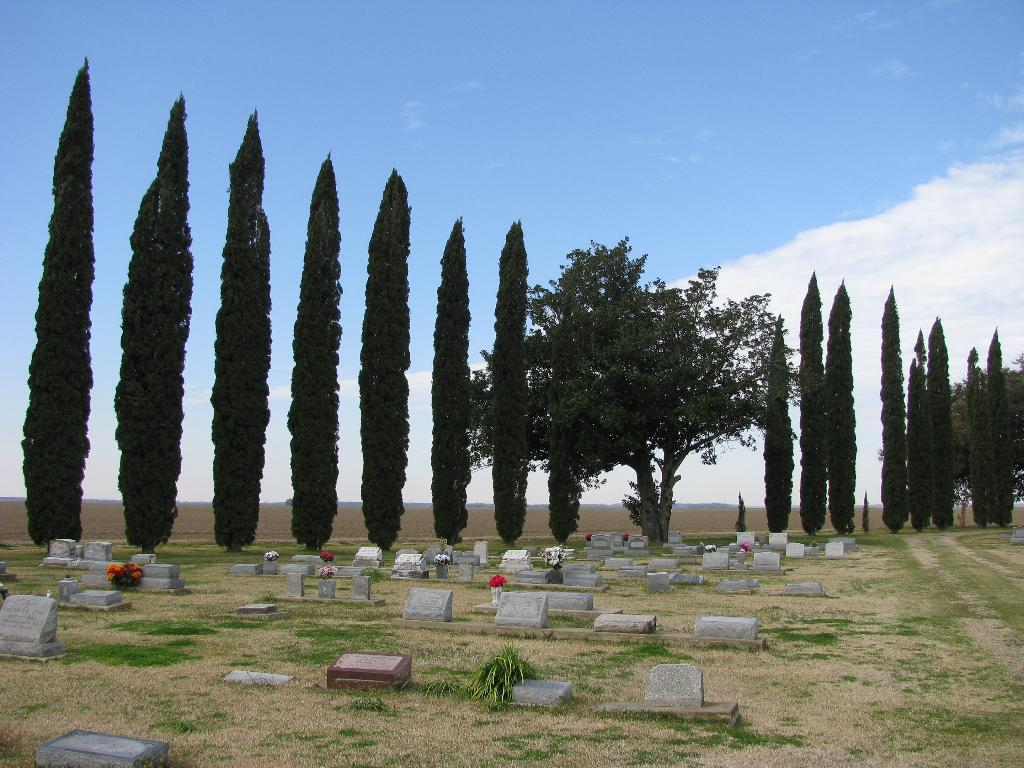What type of vegetation is present in the image? There are tall trees in the image. What can be seen in front of the trees? There are many stones in front of the trees. What might the stones resemble? The stones resemble grave stones. What memory does the son have of the gold in the image? There is no son or gold present in the image, so it is not possible to answer that question. 